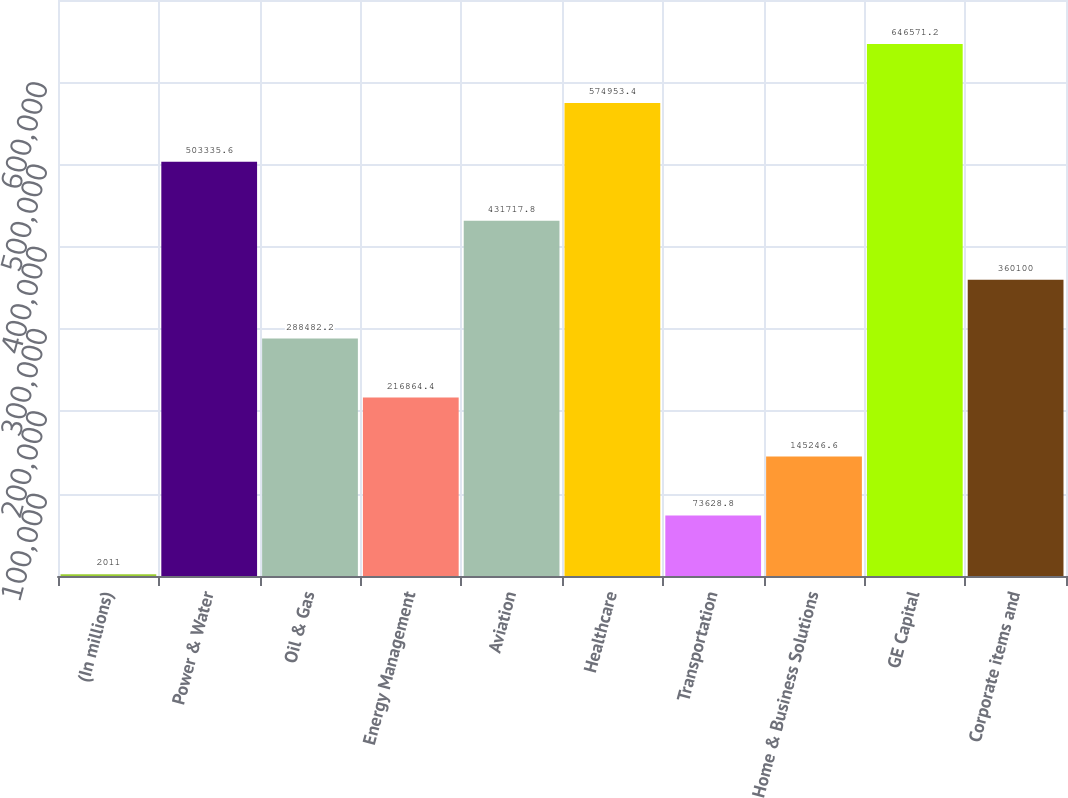<chart> <loc_0><loc_0><loc_500><loc_500><bar_chart><fcel>(In millions)<fcel>Power & Water<fcel>Oil & Gas<fcel>Energy Management<fcel>Aviation<fcel>Healthcare<fcel>Transportation<fcel>Home & Business Solutions<fcel>GE Capital<fcel>Corporate items and<nl><fcel>2011<fcel>503336<fcel>288482<fcel>216864<fcel>431718<fcel>574953<fcel>73628.8<fcel>145247<fcel>646571<fcel>360100<nl></chart> 